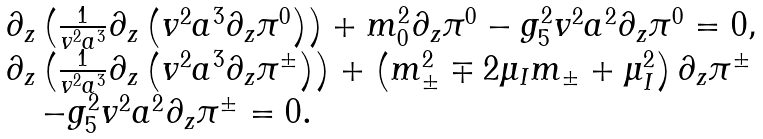<formula> <loc_0><loc_0><loc_500><loc_500>\begin{array} { l } \partial _ { z } \left ( \frac { 1 } { v ^ { 2 } a ^ { 3 } } \partial _ { z } \left ( v ^ { 2 } a ^ { 3 } \partial _ { z } \pi ^ { 0 } \right ) \right ) + m _ { 0 } ^ { 2 } \partial _ { z } \pi ^ { 0 } - g _ { 5 } ^ { 2 } v ^ { 2 } a ^ { 2 } \partial _ { z } \pi ^ { 0 } = 0 , \\ \partial _ { z } \left ( \frac { 1 } { v ^ { 2 } a ^ { 3 } } \partial _ { z } \left ( v ^ { 2 } a ^ { 3 } \partial _ { z } \pi ^ { \pm } \right ) \right ) + \left ( m _ { \pm } ^ { 2 } \mp 2 \mu _ { I } m _ { \pm } + \mu _ { I } ^ { 2 } \right ) \partial _ { z } \pi ^ { \pm } \\ \quad - g _ { 5 } ^ { 2 } v ^ { 2 } a ^ { 2 } \partial _ { z } \pi ^ { \pm } = 0 . \end{array}</formula> 